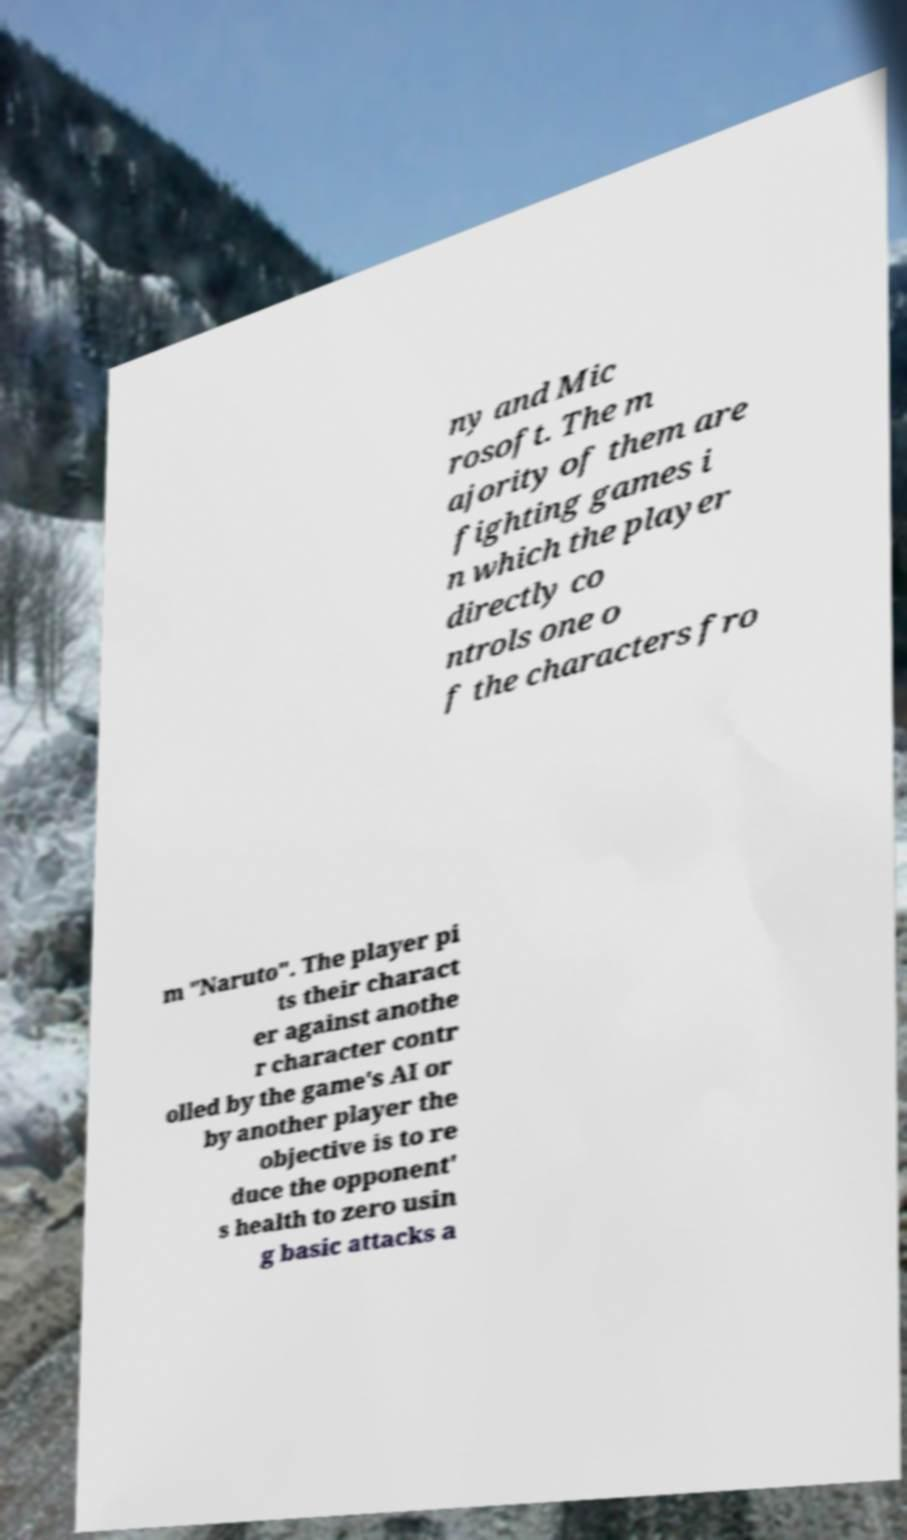What messages or text are displayed in this image? I need them in a readable, typed format. ny and Mic rosoft. The m ajority of them are fighting games i n which the player directly co ntrols one o f the characters fro m "Naruto". The player pi ts their charact er against anothe r character contr olled by the game's AI or by another player the objective is to re duce the opponent' s health to zero usin g basic attacks a 